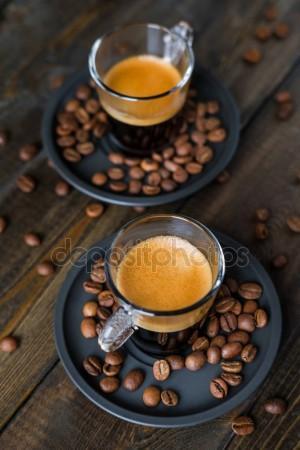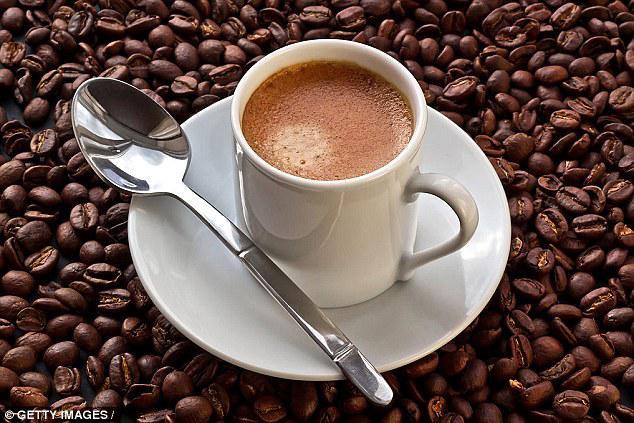The first image is the image on the left, the second image is the image on the right. Evaluate the accuracy of this statement regarding the images: "An image shows one hot beverage in a cup on a saucer that holds a spoon.". Is it true? Answer yes or no. Yes. The first image is the image on the left, the second image is the image on the right. For the images displayed, is the sentence "There are three cups of coffee on three saucers." factually correct? Answer yes or no. Yes. 